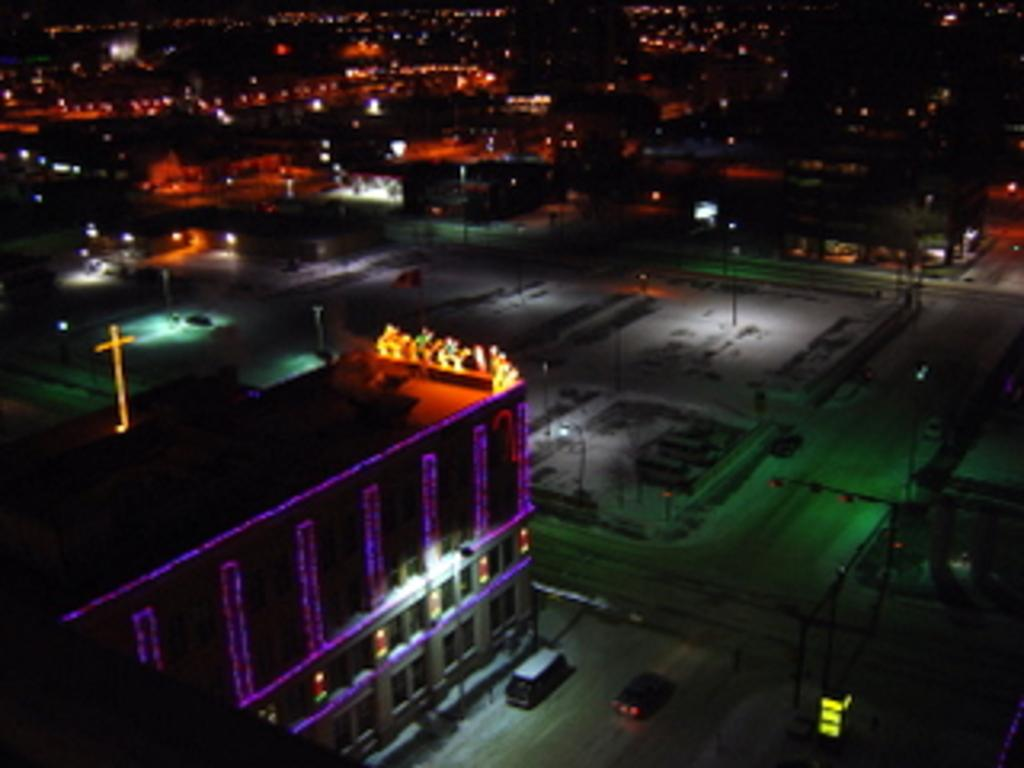What is the main feature in the center of the image? There is a road in the center of the image. What is happening on the road? Cars are present on the road. What can be seen on the left side of the image? There are buildings on the left side of the image. What is visible in the background of the image? Lights and poles are visible in the background of the image. What type of board is being used by the tail in the image? There is no board or tail present in the image. 